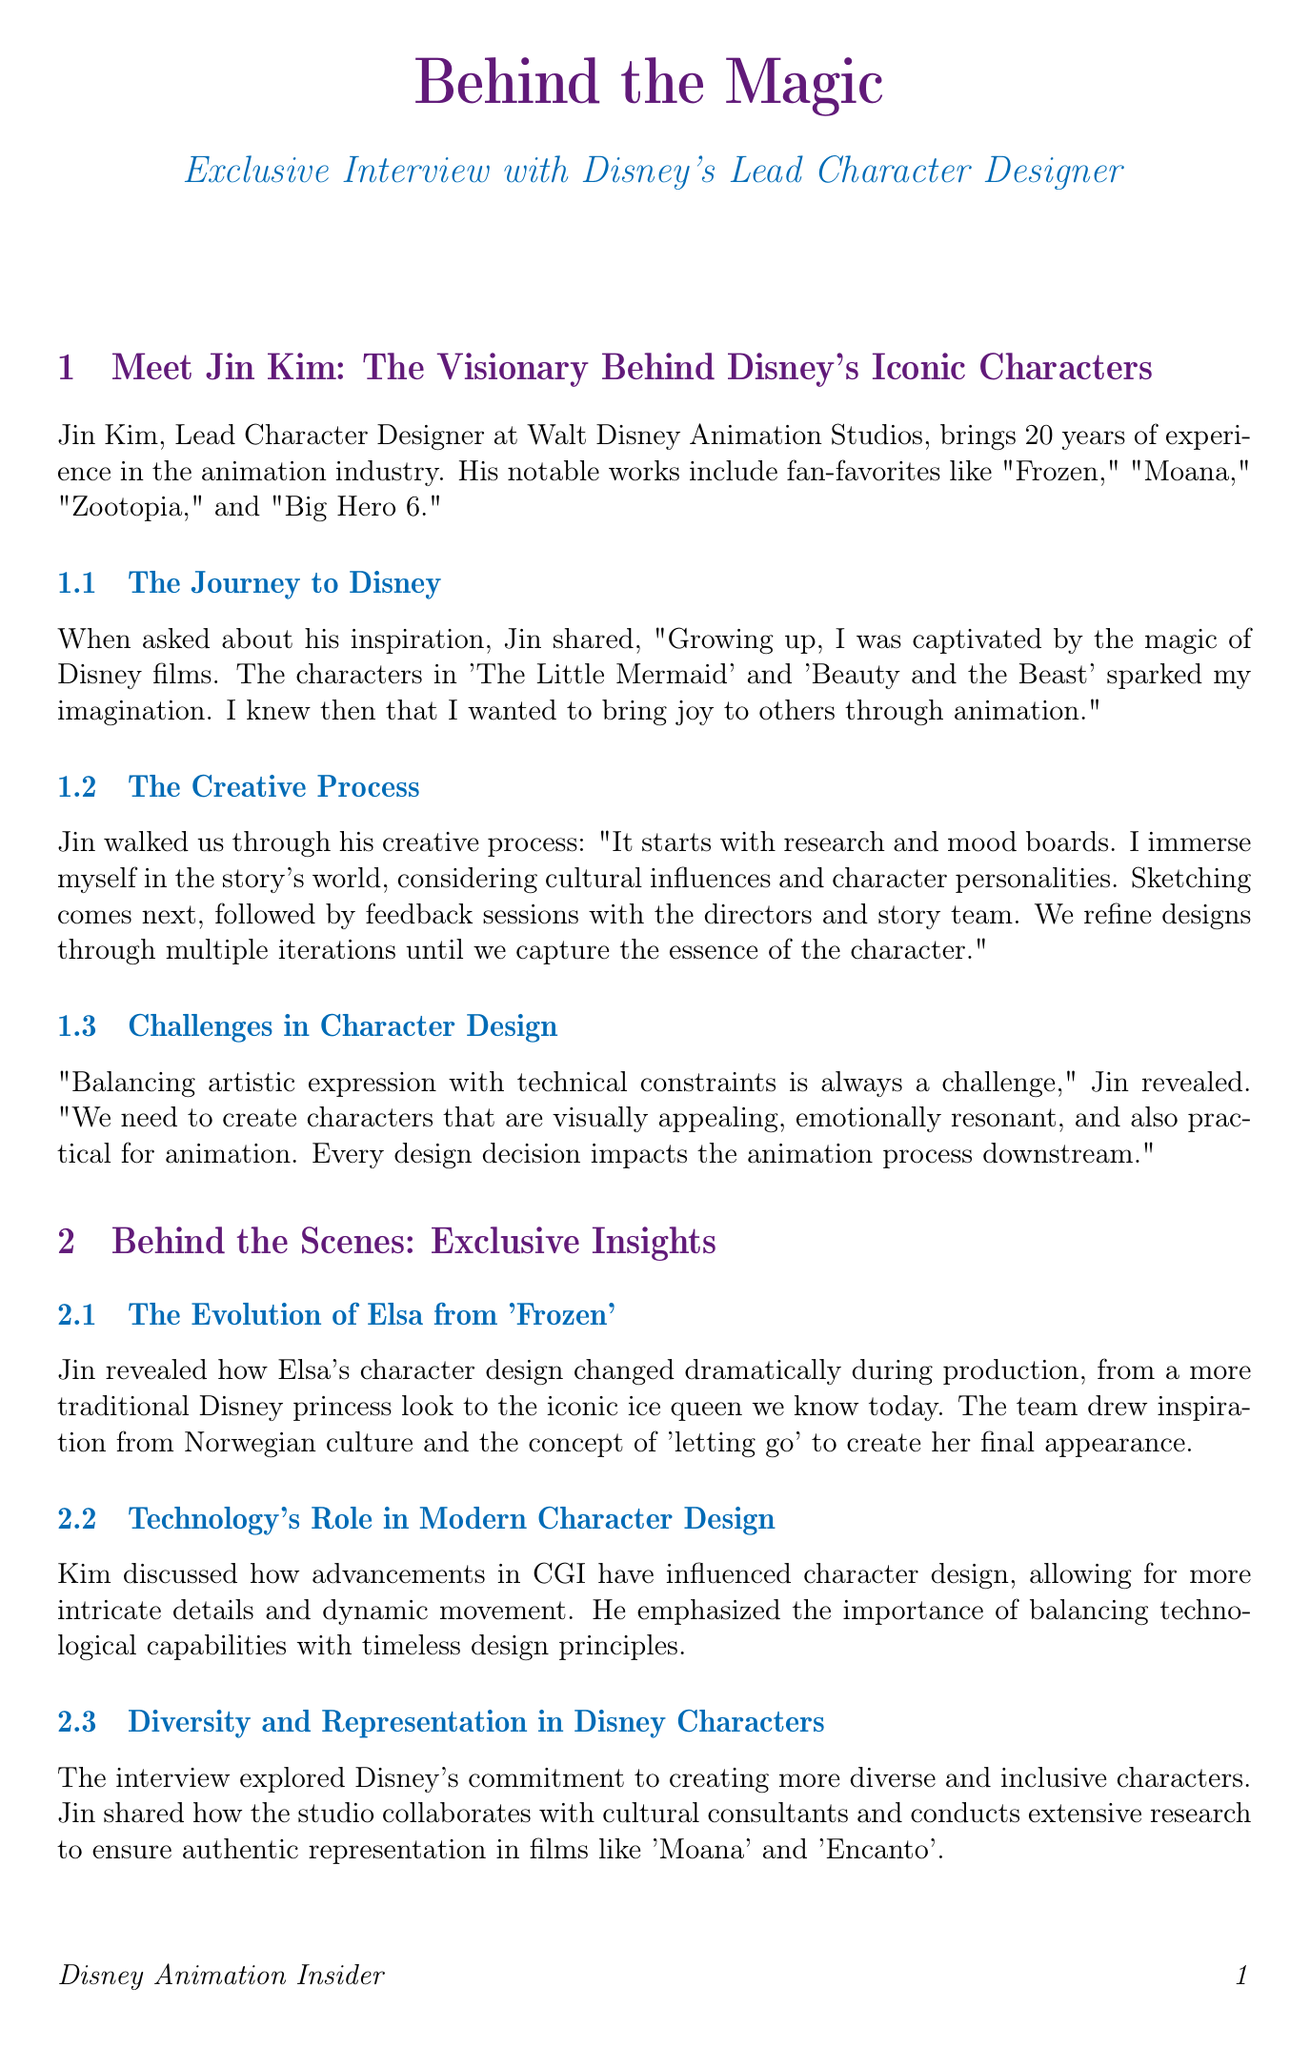What is Jin Kim's position at Disney? Jin Kim is referred to as the Lead Character Designer at Walt Disney Animation Studios.
Answer: Lead Character Designer How many years of experience does Jin Kim have in the animation industry? The document states he has 20 years of experience in the animation industry.
Answer: 20 years Which notable work features the character Elsa? The document mentions that Elsa is from the film "Frozen."
Answer: Frozen What influenced the final design of Elsa's character? The design of Elsa's character was influenced by Norwegian culture and the concept of 'letting go.'
Answer: Norwegian culture and 'letting go' What do character designers need to balance in their creations? Jin Kim highlights that character designers need to balance artistic expression with technical constraints.
Answer: Artistic expression and technical constraints Which award has Jin Kim received for his work? The document lists the Annie Award for Character Design as one of the awards Jin Kim has received.
Answer: Annie Award for Character Design What is the focus of Disney's commitment regarding character representation? The document discusses Disney's commitment to creating more diverse and inclusive characters.
Answer: Diverse and inclusive characters What kind of technology has influenced character design according to Jin Kim? Jin mentions that advancements in CGI have influenced character design.
Answer: CGI What is a personal method Jin uses to overcome creative blocks? Jin discusses sketching in public places as a method to overcome his creative blocks.
Answer: Sketching in public places 